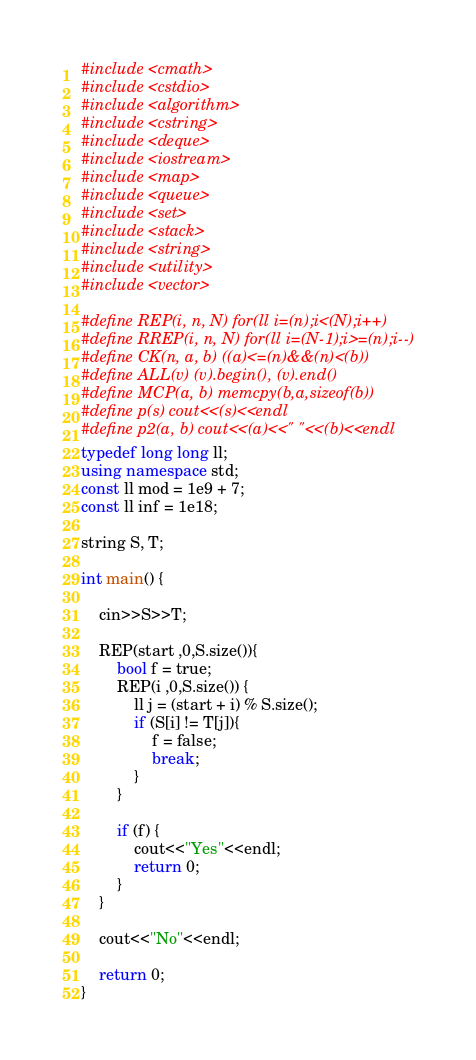<code> <loc_0><loc_0><loc_500><loc_500><_C++_>#include <cmath>
#include <cstdio>
#include <algorithm>
#include <cstring>
#include <deque>
#include <iostream>
#include <map>
#include <queue>
#include <set>
#include <stack>
#include <string>
#include <utility>
#include <vector>

#define REP(i, n, N) for(ll i=(n);i<(N);i++)
#define RREP(i, n, N) for(ll i=(N-1);i>=(n);i--)
#define CK(n, a, b) ((a)<=(n)&&(n)<(b))
#define ALL(v) (v).begin(), (v).end()
#define MCP(a, b) memcpy(b,a,sizeof(b))
#define p(s) cout<<(s)<<endl
#define p2(a, b) cout<<(a)<<" "<<(b)<<endl
typedef long long ll;
using namespace std;
const ll mod = 1e9 + 7;
const ll inf = 1e18;

string S, T;

int main() {

    cin>>S>>T;

    REP(start ,0,S.size()){
        bool f = true;
        REP(i ,0,S.size()) {
            ll j = (start + i) % S.size();
            if (S[i] != T[j]){
                f = false;
                break;
            }
        }

        if (f) {
            cout<<"Yes"<<endl;
            return 0;
        }
    }

    cout<<"No"<<endl;

    return 0;
}
</code> 